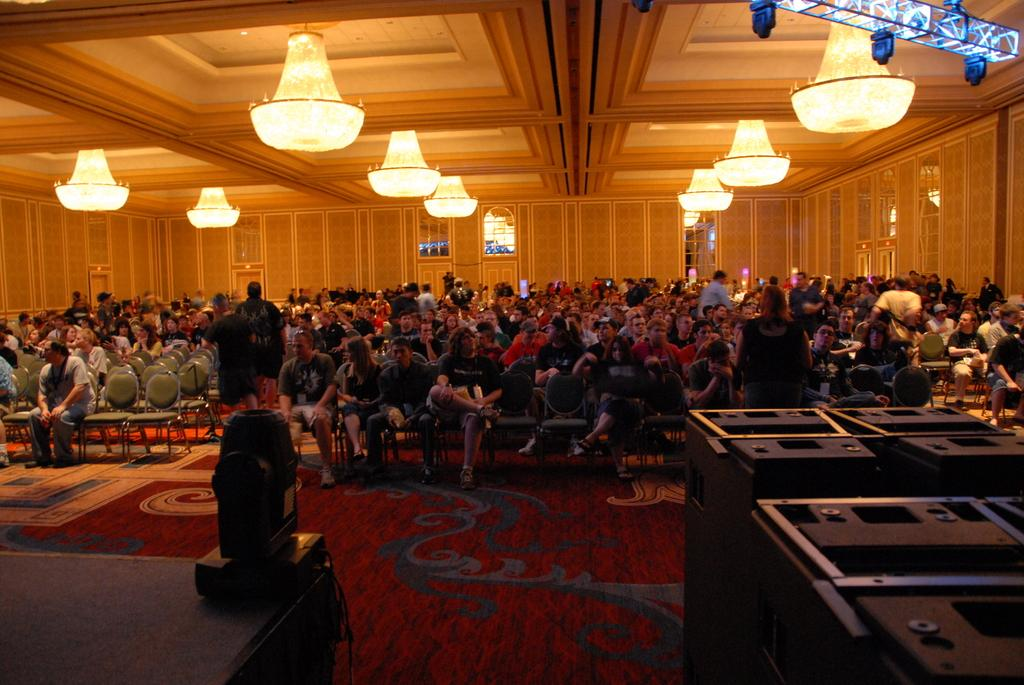What are the people in the image doing? There is a group of people sitting on chairs in the image. What is the position of the woman in the image? There is a woman standing on the floor in the image. What type of lighting fixture is present in the image? There is a chandelier in the image. Can you describe the source of light in the image? There is a light in the image. What type of architectural feature can be seen in the image? There is a wall in the image. How many rocks are visible in the image? There are no rocks present in the image. What type of star can be seen in the image? There are no stars visible in the image. 